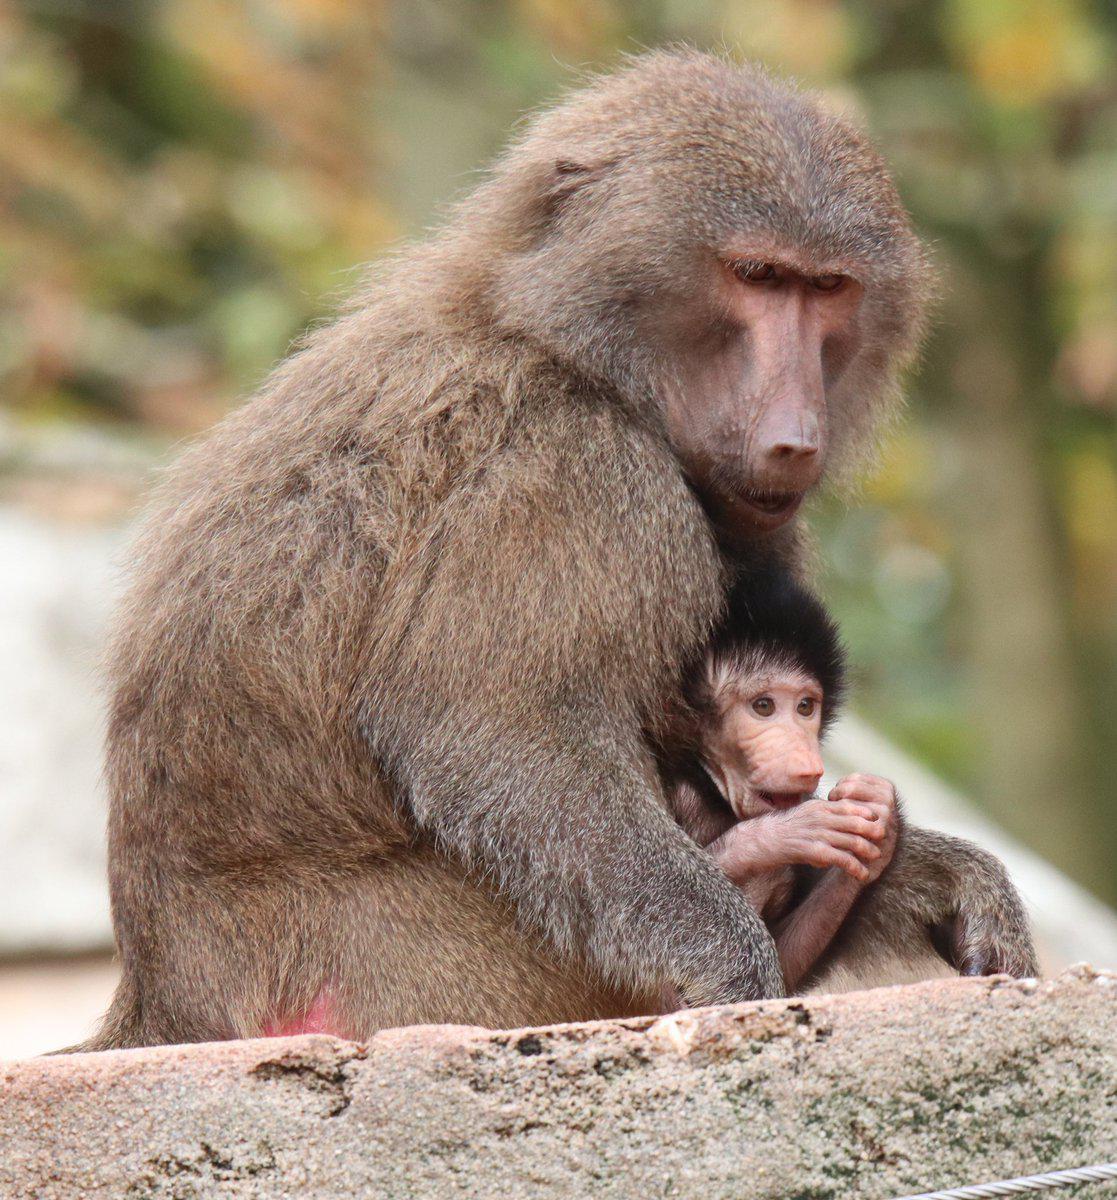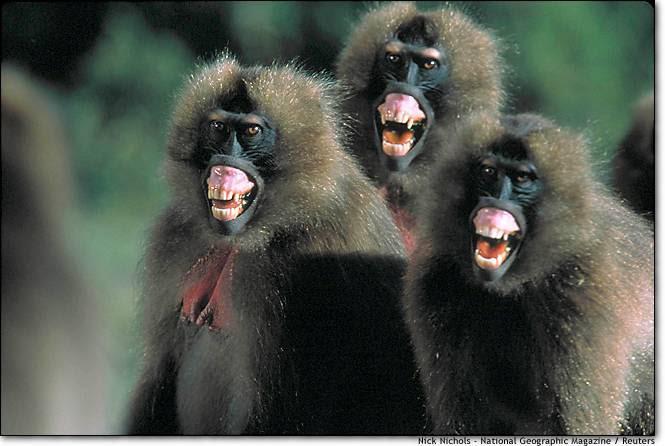The first image is the image on the left, the second image is the image on the right. Considering the images on both sides, is "The left image shows exactly one adult baboon and one baby baboon." valid? Answer yes or no. Yes. The first image is the image on the left, the second image is the image on the right. Assess this claim about the two images: "There are more monkeys in the image on the right.". Correct or not? Answer yes or no. Yes. 